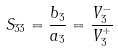<formula> <loc_0><loc_0><loc_500><loc_500>S _ { 3 3 } = \frac { b _ { 3 } } { a _ { 3 } } = \frac { V _ { 3 } ^ { - } } { V _ { 3 } ^ { + } }</formula> 